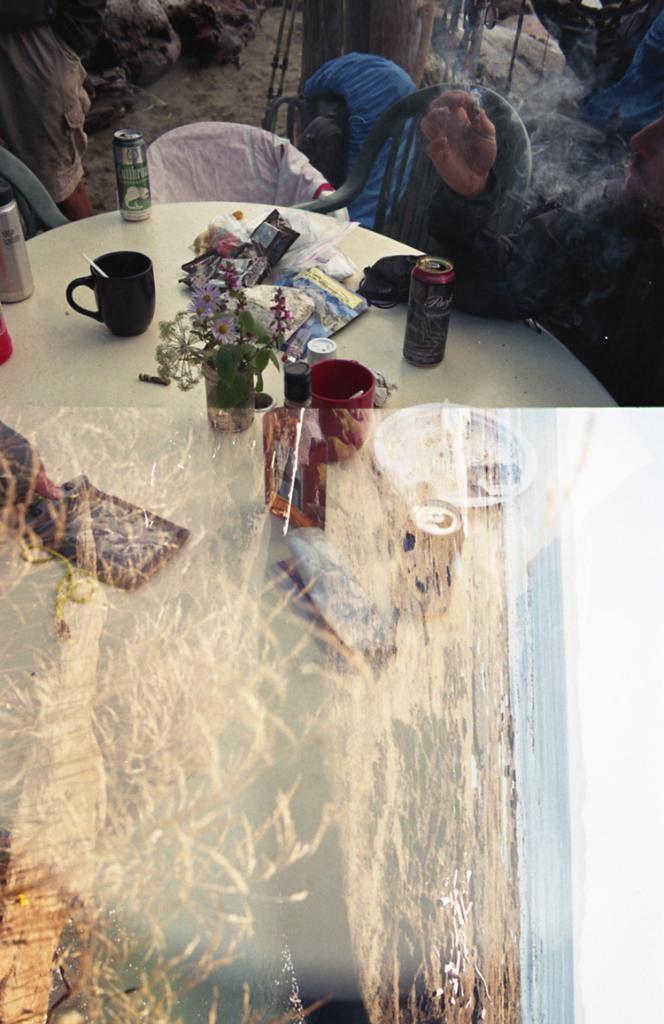Please provide a concise description of this image. In this picture I can see two images in which I can see grass, water and the sky. At the top I can see a table on which cup, cans and other items are there and three persons. This image is taken may be during a day. 